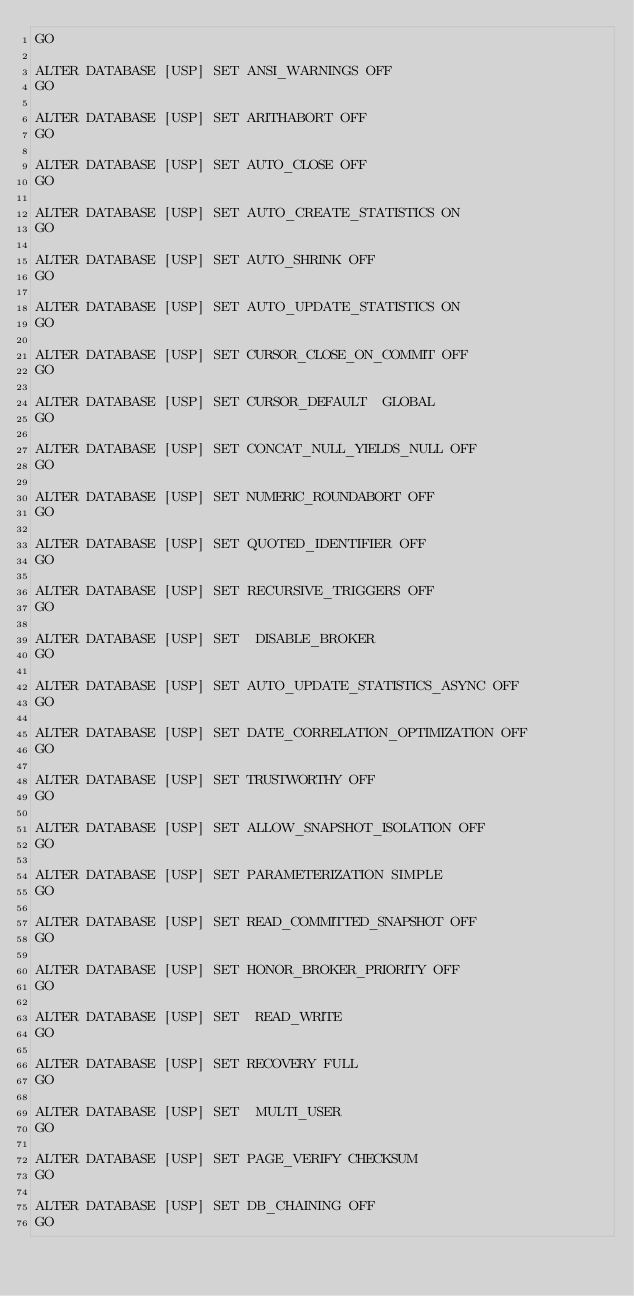<code> <loc_0><loc_0><loc_500><loc_500><_SQL_>GO

ALTER DATABASE [USP] SET ANSI_WARNINGS OFF 
GO

ALTER DATABASE [USP] SET ARITHABORT OFF 
GO

ALTER DATABASE [USP] SET AUTO_CLOSE OFF 
GO

ALTER DATABASE [USP] SET AUTO_CREATE_STATISTICS ON 
GO

ALTER DATABASE [USP] SET AUTO_SHRINK OFF 
GO

ALTER DATABASE [USP] SET AUTO_UPDATE_STATISTICS ON 
GO

ALTER DATABASE [USP] SET CURSOR_CLOSE_ON_COMMIT OFF 
GO

ALTER DATABASE [USP] SET CURSOR_DEFAULT  GLOBAL 
GO

ALTER DATABASE [USP] SET CONCAT_NULL_YIELDS_NULL OFF 
GO

ALTER DATABASE [USP] SET NUMERIC_ROUNDABORT OFF 
GO

ALTER DATABASE [USP] SET QUOTED_IDENTIFIER OFF 
GO

ALTER DATABASE [USP] SET RECURSIVE_TRIGGERS OFF 
GO

ALTER DATABASE [USP] SET  DISABLE_BROKER 
GO

ALTER DATABASE [USP] SET AUTO_UPDATE_STATISTICS_ASYNC OFF 
GO

ALTER DATABASE [USP] SET DATE_CORRELATION_OPTIMIZATION OFF 
GO

ALTER DATABASE [USP] SET TRUSTWORTHY OFF 
GO

ALTER DATABASE [USP] SET ALLOW_SNAPSHOT_ISOLATION OFF 
GO

ALTER DATABASE [USP] SET PARAMETERIZATION SIMPLE 
GO

ALTER DATABASE [USP] SET READ_COMMITTED_SNAPSHOT OFF 
GO

ALTER DATABASE [USP] SET HONOR_BROKER_PRIORITY OFF 
GO

ALTER DATABASE [USP] SET  READ_WRITE 
GO

ALTER DATABASE [USP] SET RECOVERY FULL 
GO

ALTER DATABASE [USP] SET  MULTI_USER 
GO

ALTER DATABASE [USP] SET PAGE_VERIFY CHECKSUM  
GO

ALTER DATABASE [USP] SET DB_CHAINING OFF 
GO

</code> 